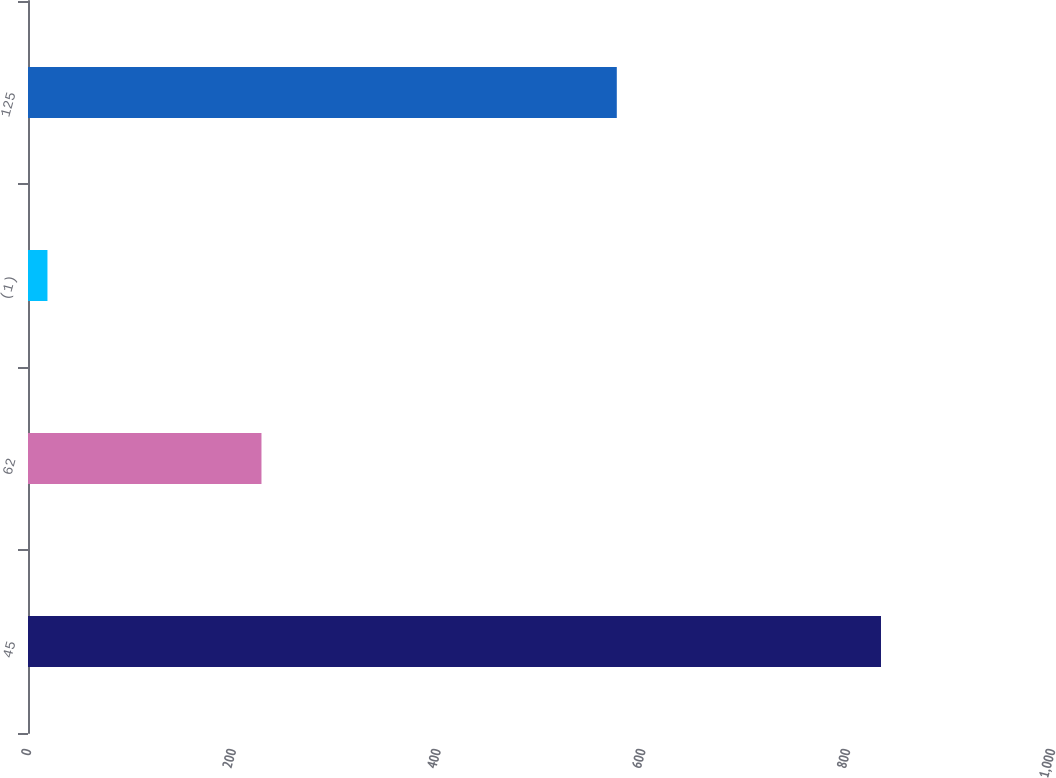Convert chart. <chart><loc_0><loc_0><loc_500><loc_500><bar_chart><fcel>45<fcel>62<fcel>(1)<fcel>125<nl><fcel>833<fcel>228<fcel>19<fcel>575<nl></chart> 